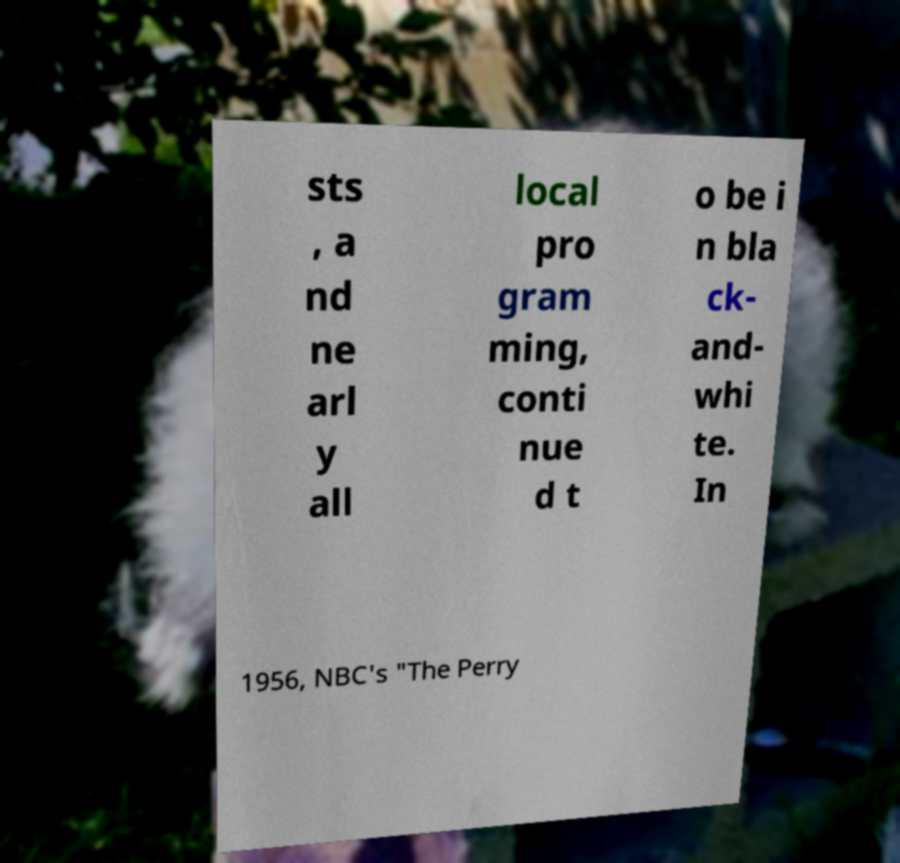Can you read and provide the text displayed in the image?This photo seems to have some interesting text. Can you extract and type it out for me? sts , a nd ne arl y all local pro gram ming, conti nue d t o be i n bla ck- and- whi te. In 1956, NBC's "The Perry 